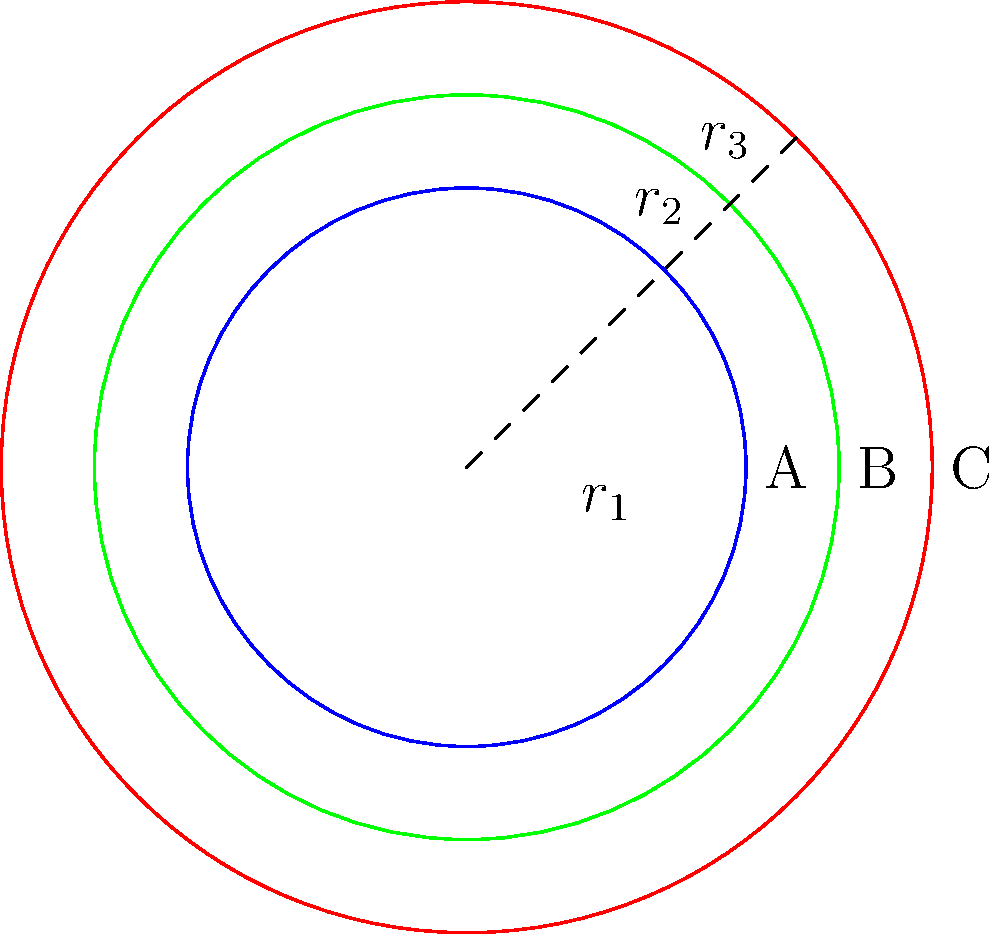A circular public plaza is being designed with two surrounding walkways. The inner circle (A) represents the main plaza area, while the two outer circles (B and C) represent the walkways. Given that the radius of the main plaza is 30 meters, and each walkway is 10 meters wide, calculate the total area of the entire structure (including the plaza and both walkways) to the nearest square meter. How does this compare to the area of just the main plaza? Let's approach this step-by-step:

1) First, let's define our radii:
   $r_1 = 30$ m (radius of main plaza)
   $r_2 = 40$ m (radius to outer edge of first walkway)
   $r_3 = 50$ m (radius to outer edge of second walkway)

2) The area of a circle is given by the formula $A = \pi r^2$

3) Area of main plaza:
   $A_1 = \pi r_1^2 = \pi (30)^2 = 900\pi$ m²

4) Total area (including both walkways):
   $A_{total} = \pi r_3^2 = \pi (50)^2 = 2500\pi$ m²

5) To get the nearest square meter:
   $A_{total} \approx 2500 \times 3.14159 \approx 7854$ m²

6) Comparison:
   Area of main plaza: $900\pi \approx 2827$ m²
   Total area: $7854$ m²
   Difference: $7854 - 2827 = 5027$ m²

7) The total area is approximately 2.78 times larger than the main plaza area.
Answer: 7854 m²; 2.78 times larger than main plaza 